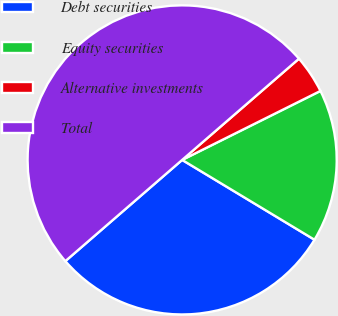<chart> <loc_0><loc_0><loc_500><loc_500><pie_chart><fcel>Debt securities<fcel>Equity securities<fcel>Alternative investments<fcel>Total<nl><fcel>30.0%<fcel>16.0%<fcel>4.0%<fcel>50.0%<nl></chart> 